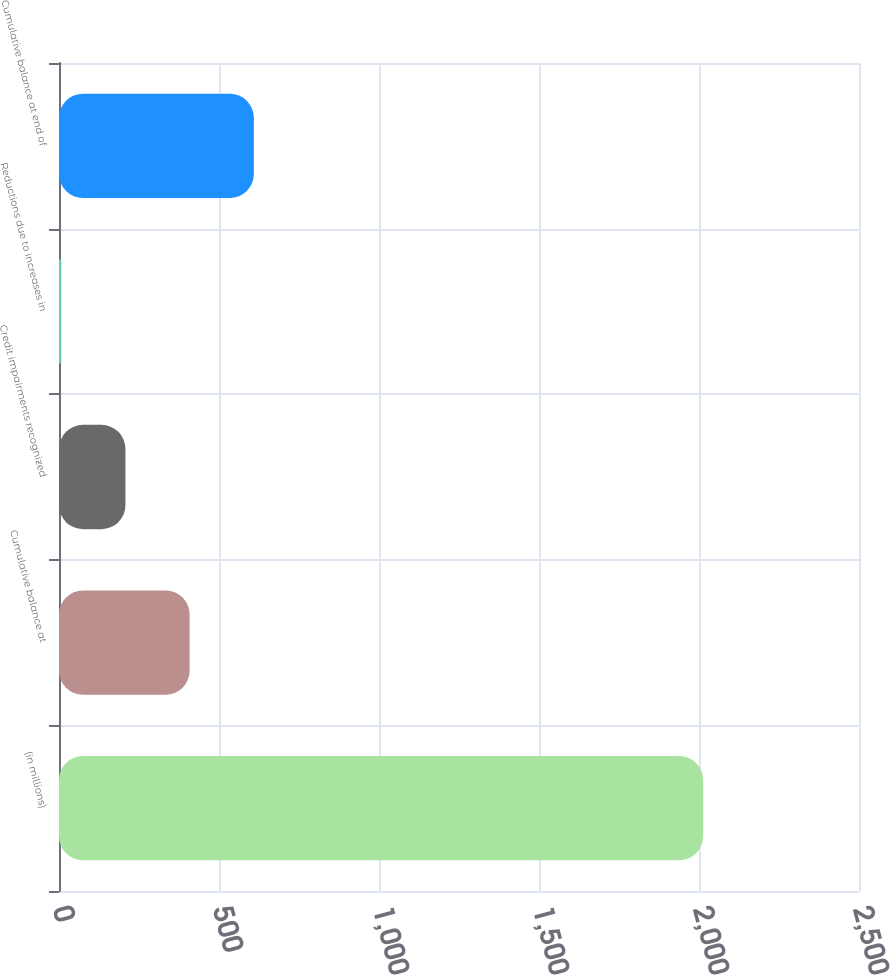Convert chart to OTSL. <chart><loc_0><loc_0><loc_500><loc_500><bar_chart><fcel>(in millions)<fcel>Cumulative balance at<fcel>Credit impairments recognized<fcel>Reductions due to increases in<fcel>Cumulative balance at end of<nl><fcel>2013<fcel>408.2<fcel>207.6<fcel>7<fcel>608.8<nl></chart> 